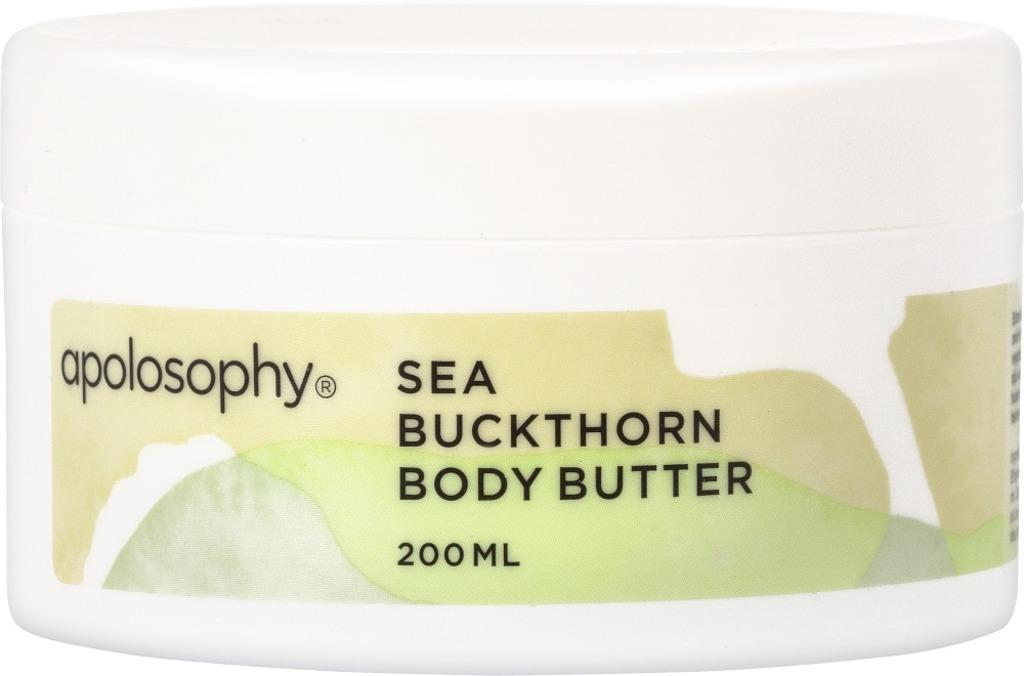Provide a one-sentence caption for the provided image. A white 200 ML container of apolosohy body butter. 